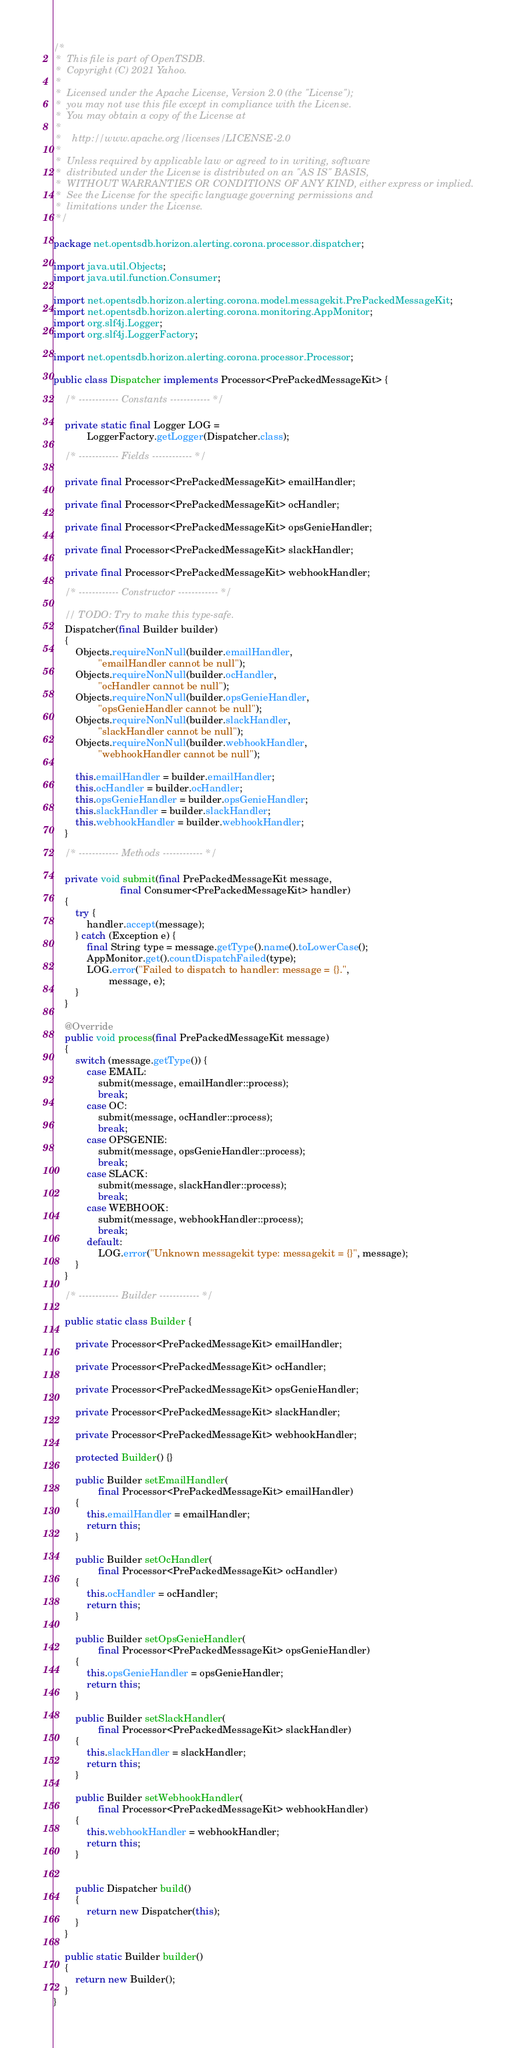<code> <loc_0><loc_0><loc_500><loc_500><_Java_>/*
 *  This file is part of OpenTSDB.
 *  Copyright (C) 2021 Yahoo.
 *
 *  Licensed under the Apache License, Version 2.0 (the "License");
 *  you may not use this file except in compliance with the License.
 *  You may obtain a copy of the License at
 *
 *    http://www.apache.org/licenses/LICENSE-2.0
 *
 *  Unless required by applicable law or agreed to in writing, software
 *  distributed under the License is distributed on an "AS IS" BASIS,
 *  WITHOUT WARRANTIES OR CONDITIONS OF ANY KIND, either express or implied.
 *  See the License for the specific language governing permissions and
 *  limitations under the License.
 */

package net.opentsdb.horizon.alerting.corona.processor.dispatcher;

import java.util.Objects;
import java.util.function.Consumer;

import net.opentsdb.horizon.alerting.corona.model.messagekit.PrePackedMessageKit;
import net.opentsdb.horizon.alerting.corona.monitoring.AppMonitor;
import org.slf4j.Logger;
import org.slf4j.LoggerFactory;

import net.opentsdb.horizon.alerting.corona.processor.Processor;

public class Dispatcher implements Processor<PrePackedMessageKit> {

    /* ------------ Constants ------------ */

    private static final Logger LOG =
            LoggerFactory.getLogger(Dispatcher.class);

    /* ------------ Fields ------------ */

    private final Processor<PrePackedMessageKit> emailHandler;

    private final Processor<PrePackedMessageKit> ocHandler;

    private final Processor<PrePackedMessageKit> opsGenieHandler;

    private final Processor<PrePackedMessageKit> slackHandler;

    private final Processor<PrePackedMessageKit> webhookHandler;

    /* ------------ Constructor ------------ */

    // TODO: Try to make this type-safe.
    Dispatcher(final Builder builder)
    {
        Objects.requireNonNull(builder.emailHandler,
                "emailHandler cannot be null");
        Objects.requireNonNull(builder.ocHandler,
                "ocHandler cannot be null");
        Objects.requireNonNull(builder.opsGenieHandler,
                "opsGenieHandler cannot be null");
        Objects.requireNonNull(builder.slackHandler,
                "slackHandler cannot be null");
        Objects.requireNonNull(builder.webhookHandler,
                "webhookHandler cannot be null");

        this.emailHandler = builder.emailHandler;
        this.ocHandler = builder.ocHandler;
        this.opsGenieHandler = builder.opsGenieHandler;
        this.slackHandler = builder.slackHandler;
        this.webhookHandler = builder.webhookHandler;
    }

    /* ------------ Methods ------------ */

    private void submit(final PrePackedMessageKit message,
                        final Consumer<PrePackedMessageKit> handler)
    {
        try {
            handler.accept(message);
        } catch (Exception e) {
            final String type = message.getType().name().toLowerCase();
            AppMonitor.get().countDispatchFailed(type);
            LOG.error("Failed to dispatch to handler: message = {}.",
                    message, e);
        }
    }

    @Override
    public void process(final PrePackedMessageKit message)
    {
        switch (message.getType()) {
            case EMAIL:
                submit(message, emailHandler::process);
                break;
            case OC:
                submit(message, ocHandler::process);
                break;
            case OPSGENIE:
                submit(message, opsGenieHandler::process);
                break;
            case SLACK:
                submit(message, slackHandler::process);
                break;
            case WEBHOOK:
                submit(message, webhookHandler::process);
                break;
            default:
                LOG.error("Unknown messagekit type: messagekit = {}", message);
        }
    }

    /* ------------ Builder ------------ */

    public static class Builder {

        private Processor<PrePackedMessageKit> emailHandler;

        private Processor<PrePackedMessageKit> ocHandler;

        private Processor<PrePackedMessageKit> opsGenieHandler;

        private Processor<PrePackedMessageKit> slackHandler;

        private Processor<PrePackedMessageKit> webhookHandler;

        protected Builder() {}

        public Builder setEmailHandler(
                final Processor<PrePackedMessageKit> emailHandler)
        {
            this.emailHandler = emailHandler;
            return this;
        }

        public Builder setOcHandler(
                final Processor<PrePackedMessageKit> ocHandler)
        {
            this.ocHandler = ocHandler;
            return this;
        }

        public Builder setOpsGenieHandler(
                final Processor<PrePackedMessageKit> opsGenieHandler)
        {
            this.opsGenieHandler = opsGenieHandler;
            return this;
        }

        public Builder setSlackHandler(
                final Processor<PrePackedMessageKit> slackHandler)
        {
            this.slackHandler = slackHandler;
            return this;
        }

        public Builder setWebhookHandler(
                final Processor<PrePackedMessageKit> webhookHandler)
        {
            this.webhookHandler = webhookHandler;
            return this;
        }


        public Dispatcher build()
        {
            return new Dispatcher(this);
        }
    }

    public static Builder builder()
    {
        return new Builder();
    }
}
</code> 